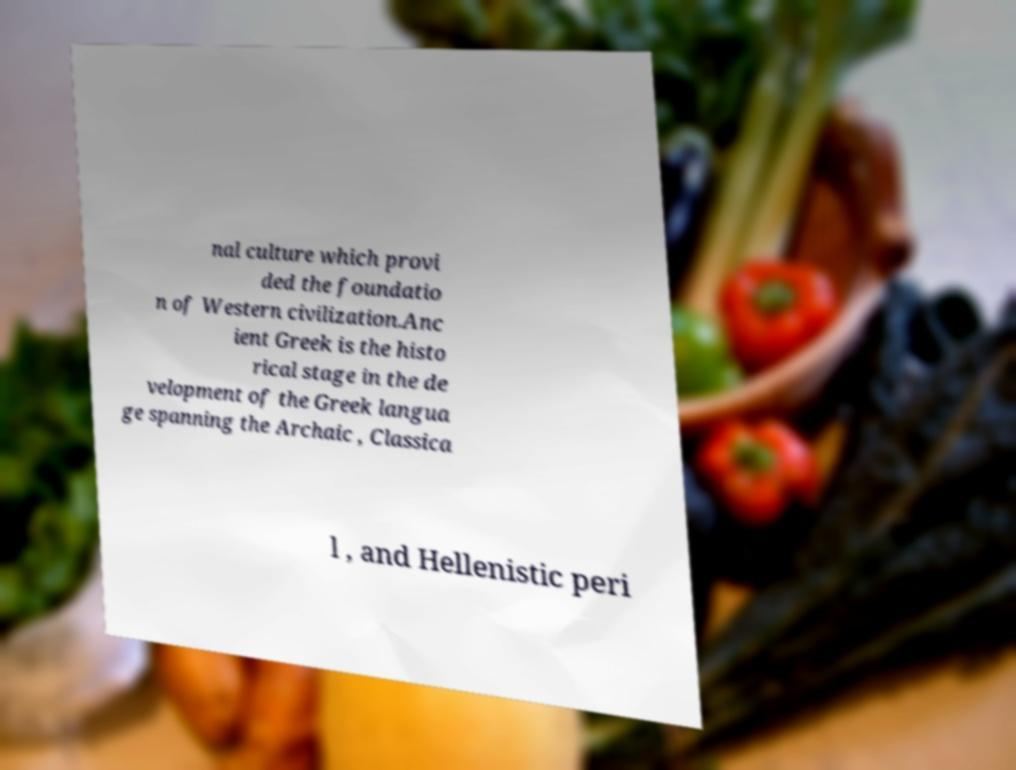Please read and relay the text visible in this image. What does it say? nal culture which provi ded the foundatio n of Western civilization.Anc ient Greek is the histo rical stage in the de velopment of the Greek langua ge spanning the Archaic , Classica l , and Hellenistic peri 